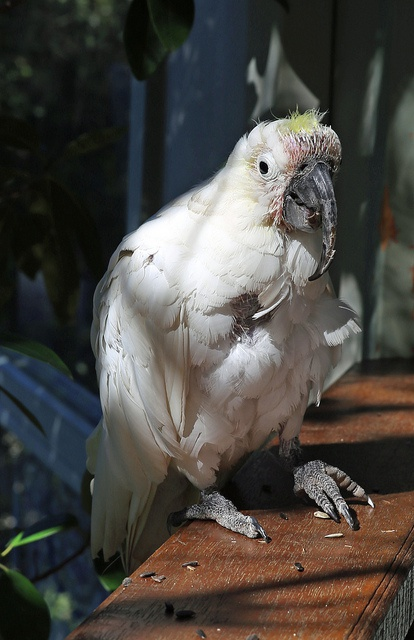Describe the objects in this image and their specific colors. I can see a bird in black, gray, lightgray, and darkgray tones in this image. 